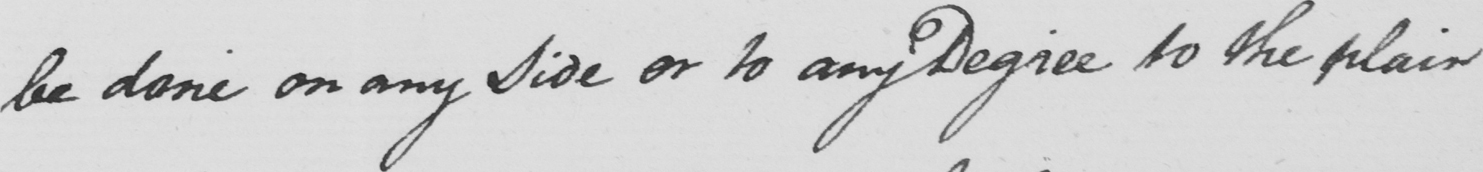Can you tell me what this handwritten text says? be done on any Side or to any Degree to the plain 